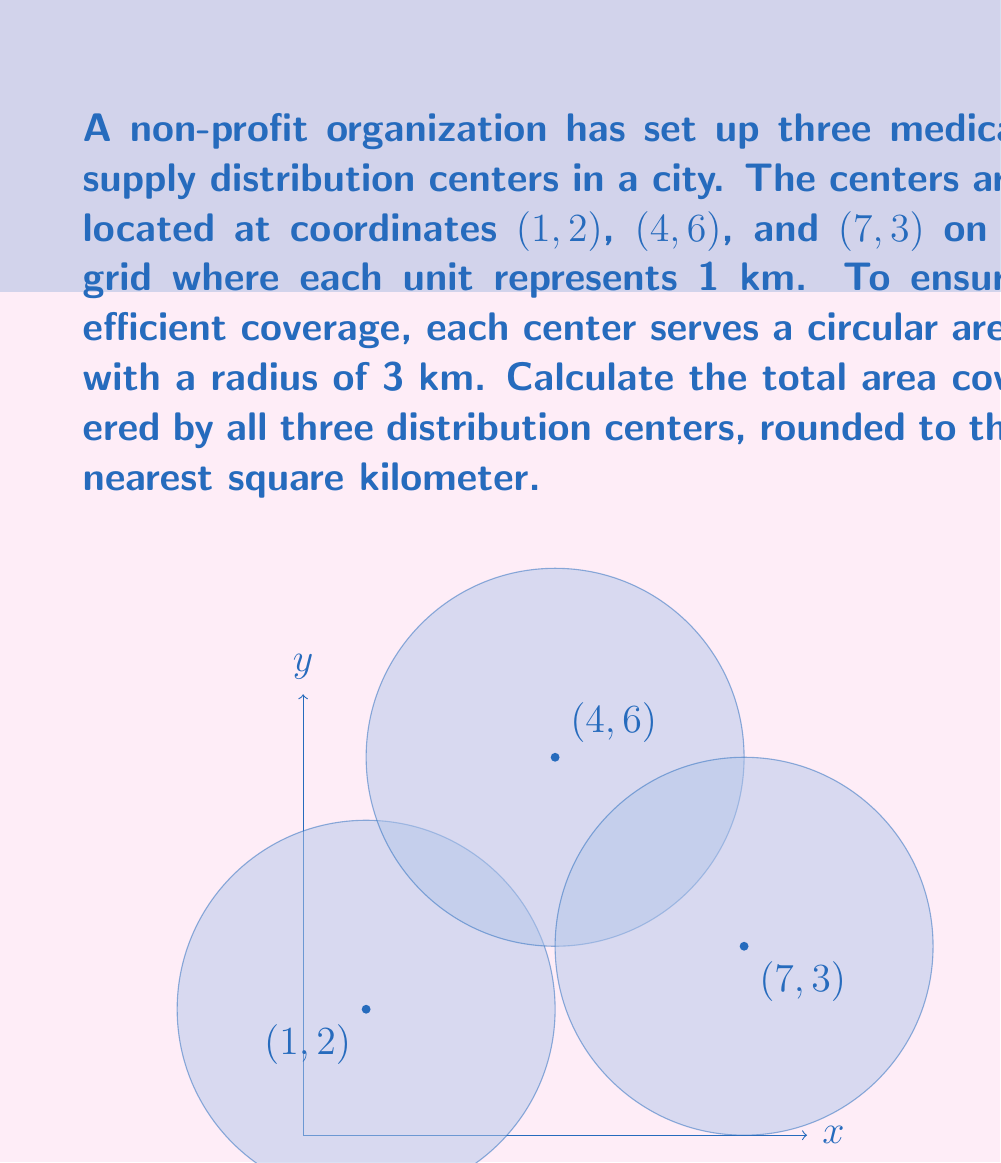Give your solution to this math problem. To solve this problem, we need to follow these steps:

1) First, calculate the area of a single circular distribution zone:
   $$ A = \pi r^2 = \pi (3 \text{ km})^2 = 9\pi \text{ km}^2 $$

2) The total area covered by all three circles would be $27\pi \text{ km}^2$ if they didn't overlap. However, we need to account for potential overlap.

3) To check for overlap, we calculate the distances between the centers:
   
   Between (1,2) and (4,6): 
   $$ d = \sqrt{(4-1)^2 + (6-2)^2} = \sqrt{3^2 + 4^2} = 5 \text{ km} $$
   
   Between (4,6) and (7,3):
   $$ d = \sqrt{(7-4)^2 + (3-6)^2} = \sqrt{3^2 + (-3)^2} = 4.24 \text{ km} $$
   
   Between (1,2) and (7,3):
   $$ d = \sqrt{(7-1)^2 + (3-2)^2} = \sqrt{6^2 + 1^2} = 6.08 \text{ km} $$

4) Since the radius of each circle is 3 km, circles overlap if their centers are less than 6 km apart. We see that the circles centered at (4,6) and (7,3) overlap.

5) To calculate the overlap area, we use the formula for the area of intersection of two circles:

   $$ A = 2r^2 \arccos(\frac{d}{2r}) - d\sqrt{r^2 - (\frac{d}{2})^2} $$

   Where $r = 3$ and $d = 4.24$

6) Plugging in the values:

   $$ A = 2(3^2) \arccos(\frac{4.24}{2(3)}) - 4.24\sqrt{3^2 - (\frac{4.24}{2})^2} $$
   $$ A \approx 2.94 \text{ km}^2 $$

7) Therefore, the total area covered is:
   $$ \text{Total Area} = 3(9\pi) - 2.94 \approx 81.53 \text{ km}^2 $$

8) Rounding to the nearest square kilometer:
   $$ \text{Total Area} \approx 82 \text{ km}^2 $$
Answer: 82 km² 